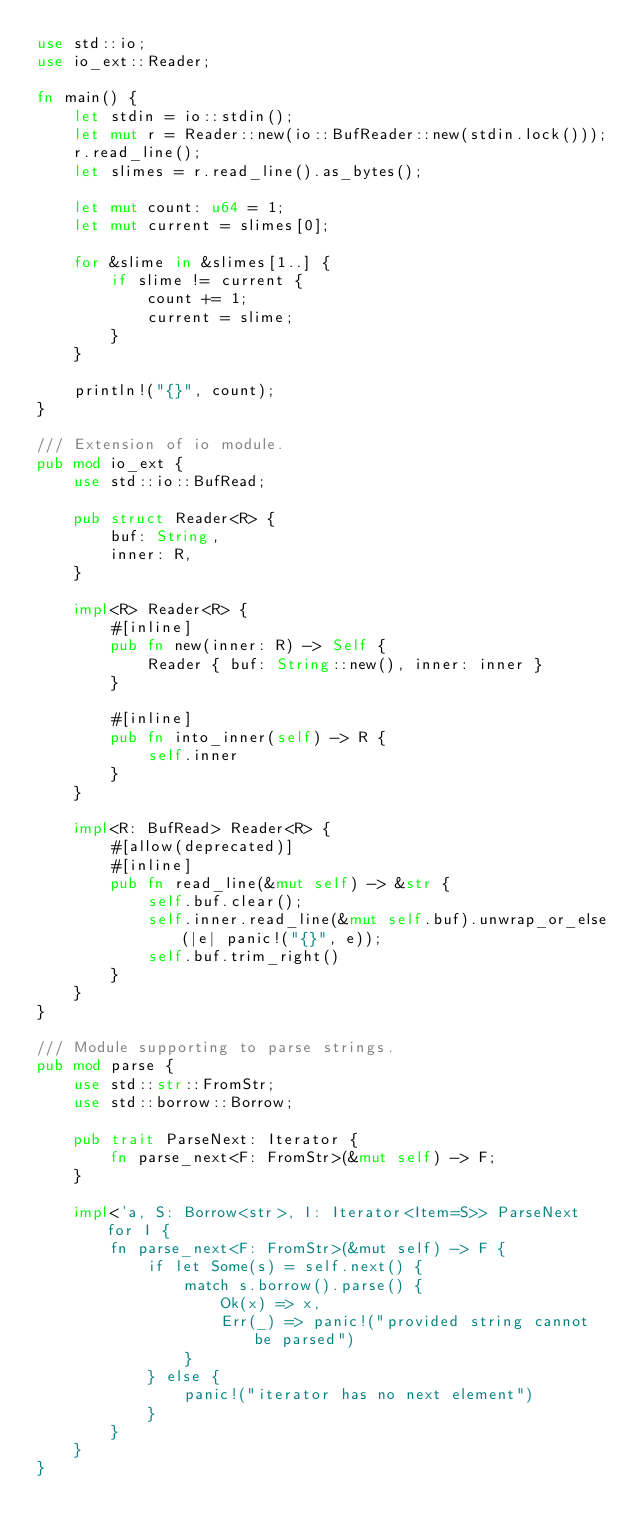Convert code to text. <code><loc_0><loc_0><loc_500><loc_500><_Rust_>use std::io;
use io_ext::Reader;

fn main() {
    let stdin = io::stdin();
    let mut r = Reader::new(io::BufReader::new(stdin.lock()));
    r.read_line();
    let slimes = r.read_line().as_bytes();

    let mut count: u64 = 1;
    let mut current = slimes[0];

    for &slime in &slimes[1..] {
        if slime != current {
            count += 1;
            current = slime;
        }
    }

    println!("{}", count);
}

/// Extension of io module.
pub mod io_ext {
    use std::io::BufRead;

    pub struct Reader<R> {
        buf: String,
        inner: R,
    }

    impl<R> Reader<R> {
        #[inline]
        pub fn new(inner: R) -> Self {
            Reader { buf: String::new(), inner: inner }
        }

        #[inline]
        pub fn into_inner(self) -> R {
            self.inner
        }
    }

    impl<R: BufRead> Reader<R> {
        #[allow(deprecated)]
        #[inline]
        pub fn read_line(&mut self) -> &str {
            self.buf.clear();
            self.inner.read_line(&mut self.buf).unwrap_or_else(|e| panic!("{}", e));
            self.buf.trim_right()
        }
    }
}

/// Module supporting to parse strings.
pub mod parse {
    use std::str::FromStr;
    use std::borrow::Borrow;

    pub trait ParseNext: Iterator {
        fn parse_next<F: FromStr>(&mut self) -> F;
    }

    impl<'a, S: Borrow<str>, I: Iterator<Item=S>> ParseNext for I {
        fn parse_next<F: FromStr>(&mut self) -> F {
            if let Some(s) = self.next() {
                match s.borrow().parse() {
                    Ok(x) => x,
                    Err(_) => panic!("provided string cannot be parsed")
                }
            } else {
                panic!("iterator has no next element")
            }
        }
    }
}
</code> 